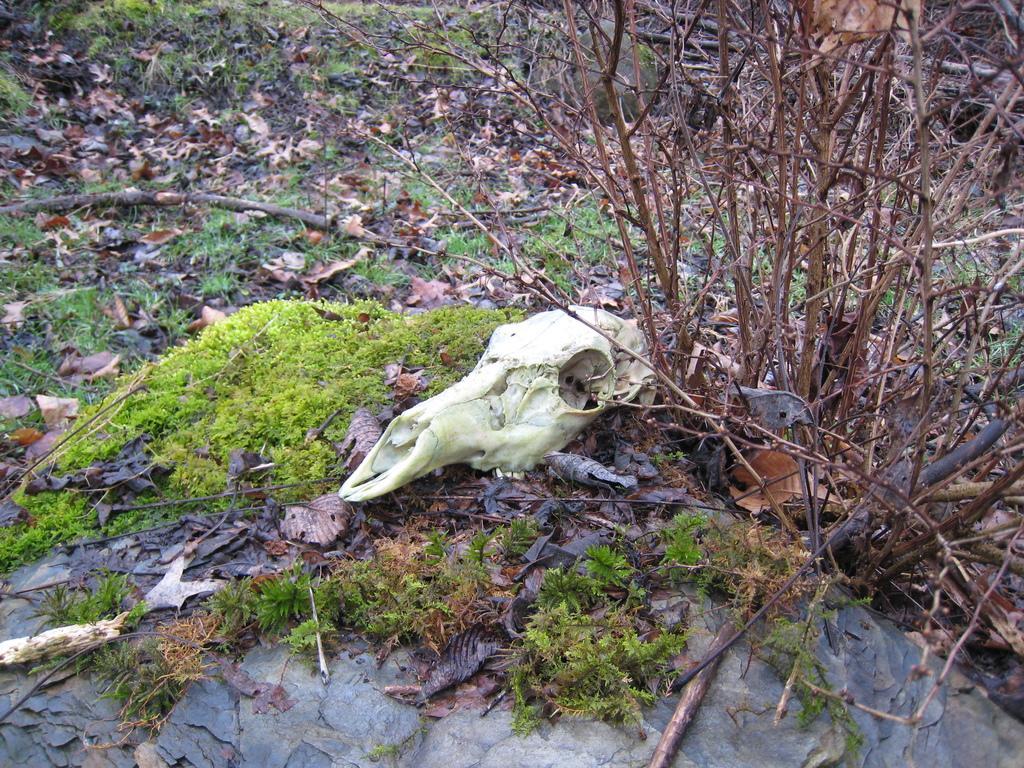How would you summarize this image in a sentence or two? In this image, this looks like a skeleton. This is the grass and the dried leaves. These are the branches. 